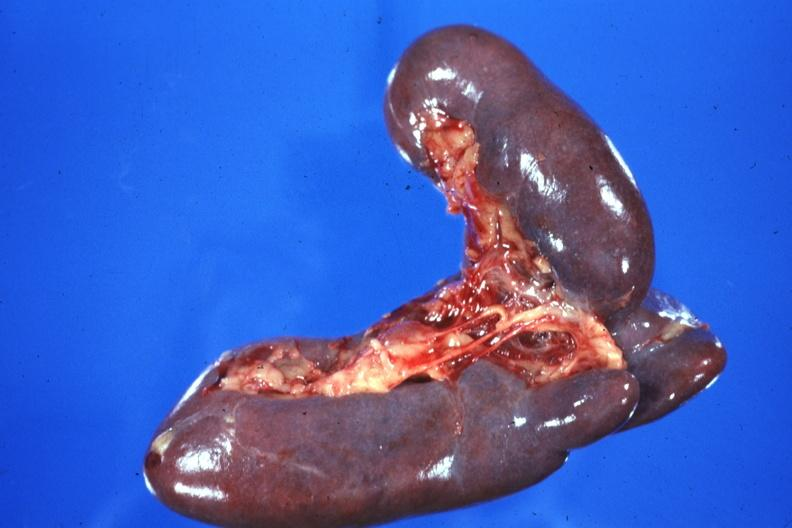s this good yellow color slide present?
Answer the question using a single word or phrase. No 